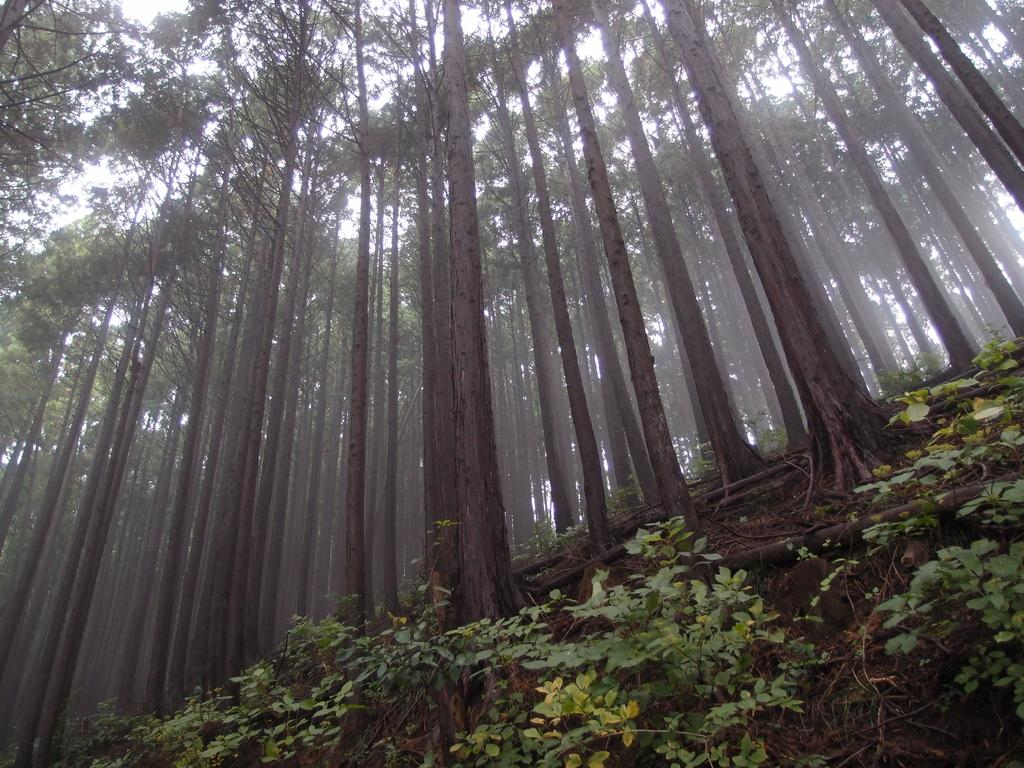What type of vegetation can be seen in the image? There is a group of trees in the image, and plants are also visible. What part of the trees is visible in the image? The bark of the trees is visible. What is visible in the background of the image? The sky is visible in the image. Where is the crate of cushions located in the image? There is no crate or cushions present in the image. 